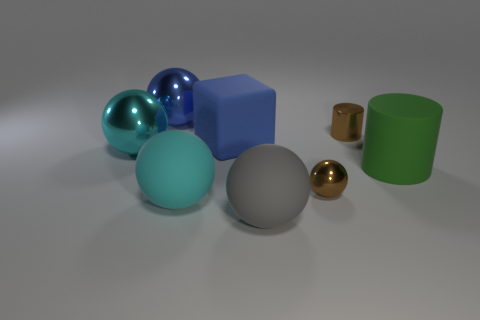What materials do the objects in the image appear to be made of? The objects in the image feature a variety of materials, each with distinct visual textures and reflections. The spheres to the left display characteristics of glossy, reflective surfaces hinting at metallic or glass properties. The large cube in the center has a matte, slightly textured appearance suggesting a plastic or painted wood material. The cylinder to the right appears to have a more matte and rough finish, potentially resembling ceramic or stone. 